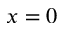Convert formula to latex. <formula><loc_0><loc_0><loc_500><loc_500>x = 0</formula> 